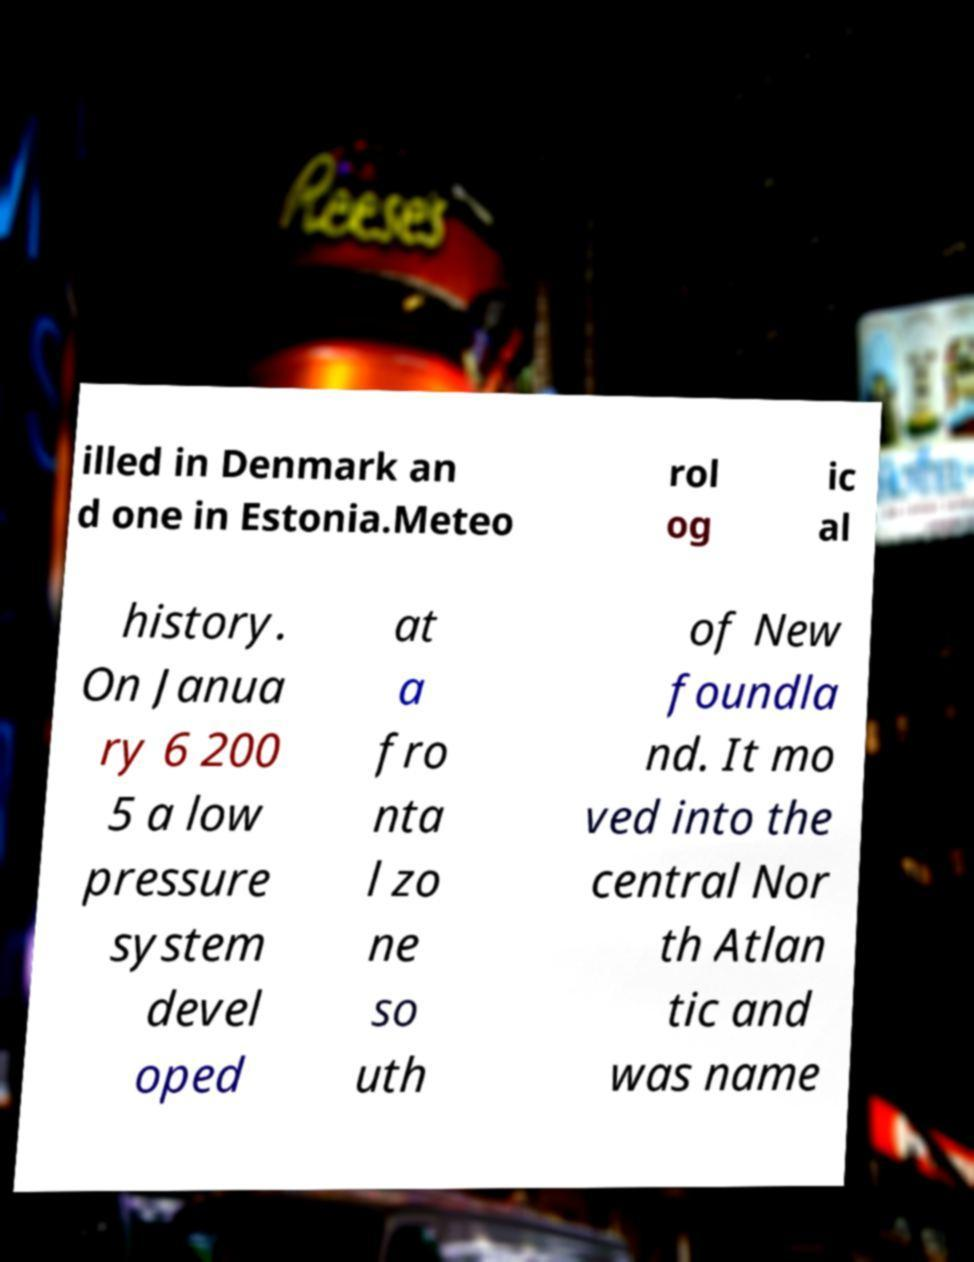Please identify and transcribe the text found in this image. illed in Denmark an d one in Estonia.Meteo rol og ic al history. On Janua ry 6 200 5 a low pressure system devel oped at a fro nta l zo ne so uth of New foundla nd. It mo ved into the central Nor th Atlan tic and was name 